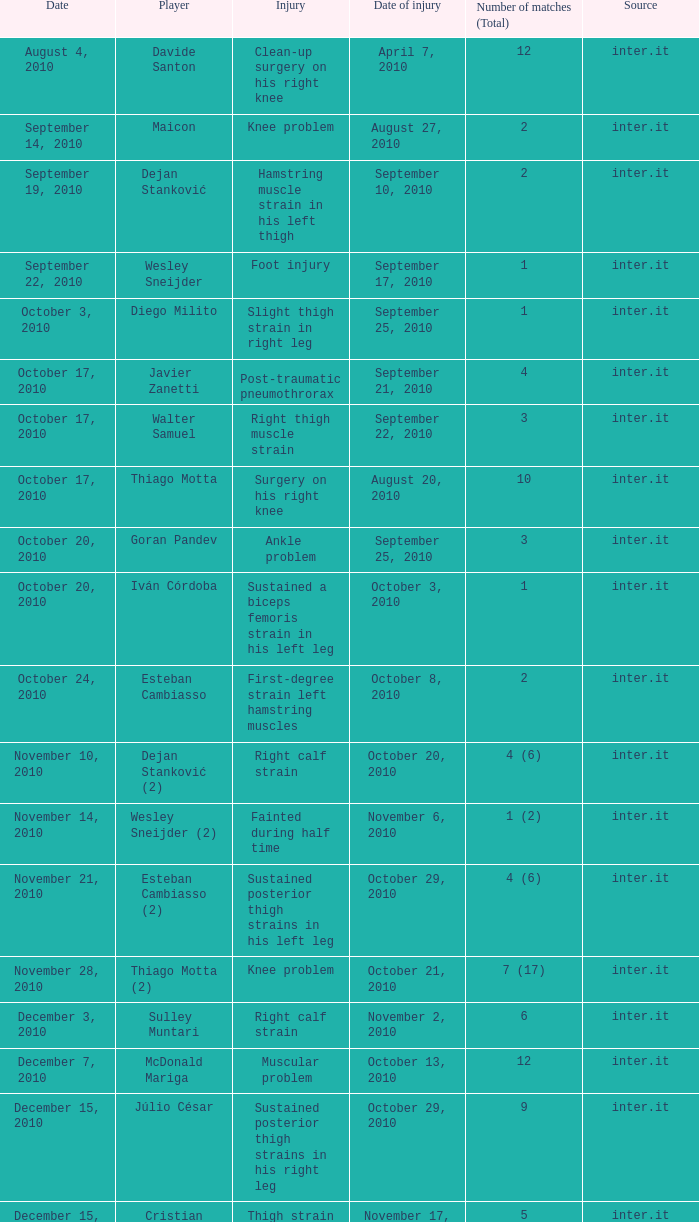How many times was the date october 3, 2010? 1.0. 